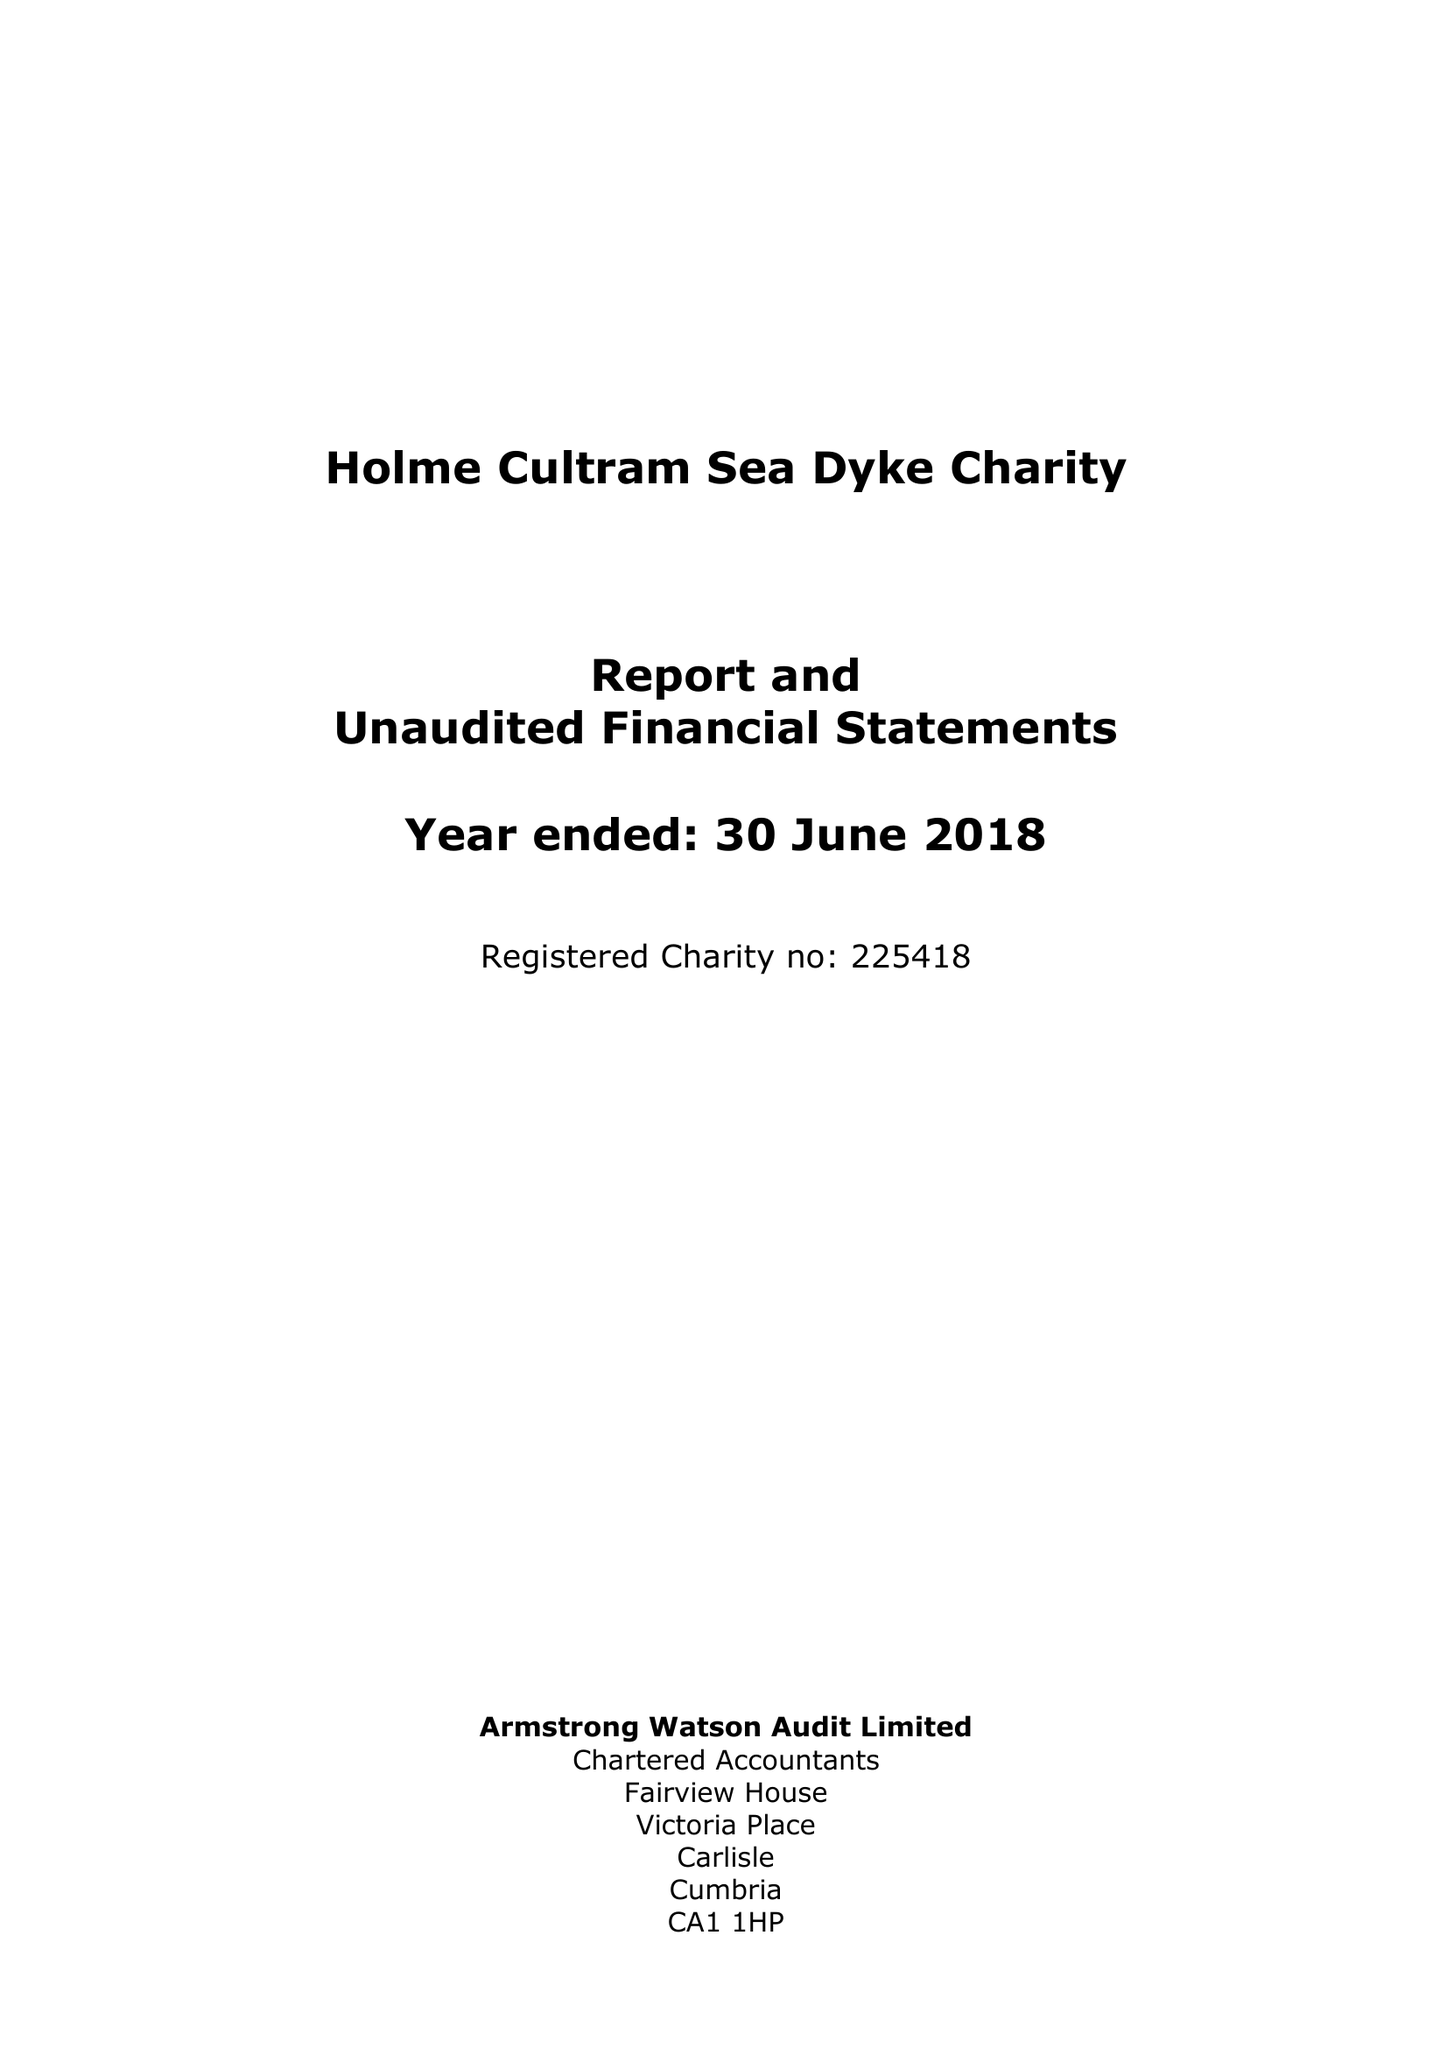What is the value for the address__street_line?
Answer the question using a single word or phrase. None 